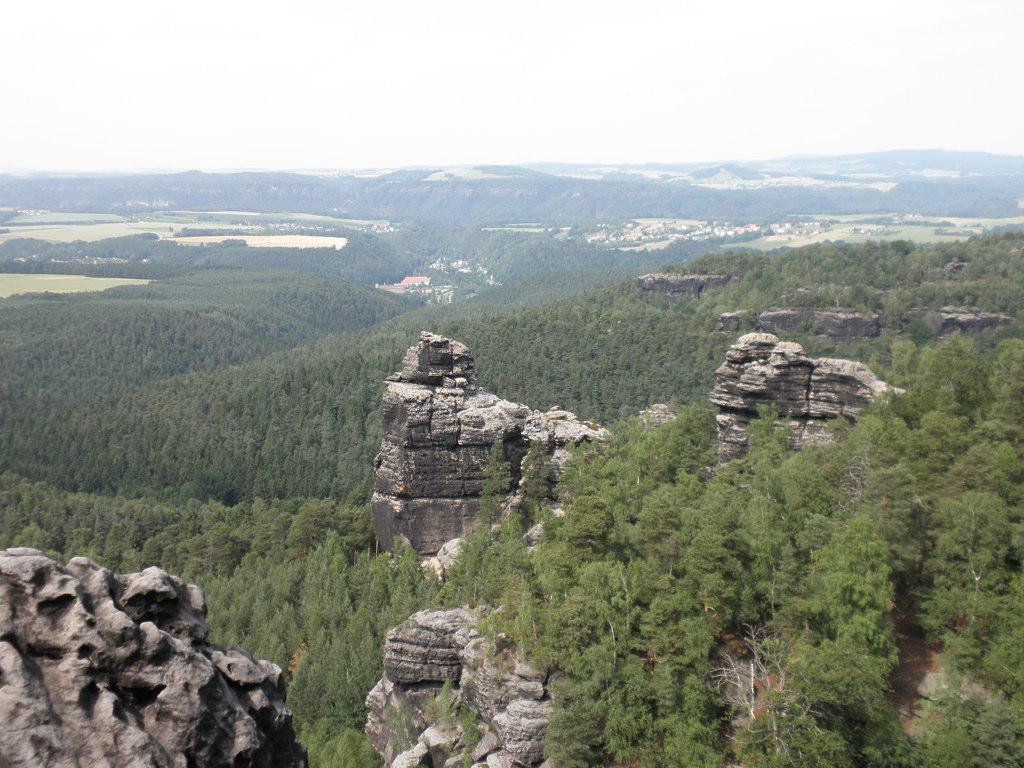What can be seen in the sky in the image? The sky is visible in the image. What type of natural features are present in the image? There are hills and trees in the image. What is visible at the bottom of the image? The ground is visible in the image. Can you tell me where the brother is teaching in the image? There is no brother or teaching activity present in the image. What type of basket is visible in the image? There is no basket present in the image. 